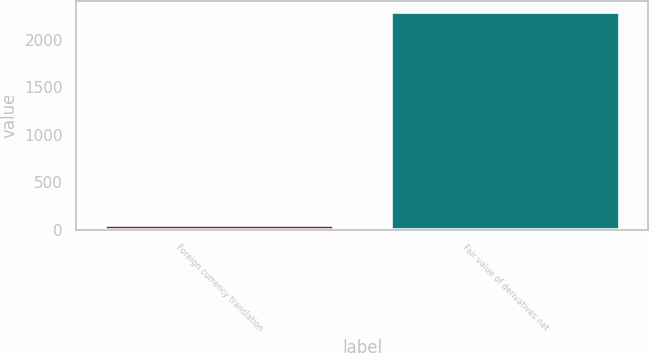Convert chart. <chart><loc_0><loc_0><loc_500><loc_500><bar_chart><fcel>Foreign currency translation<fcel>Fair value of derivatives net<nl><fcel>45<fcel>2294<nl></chart> 